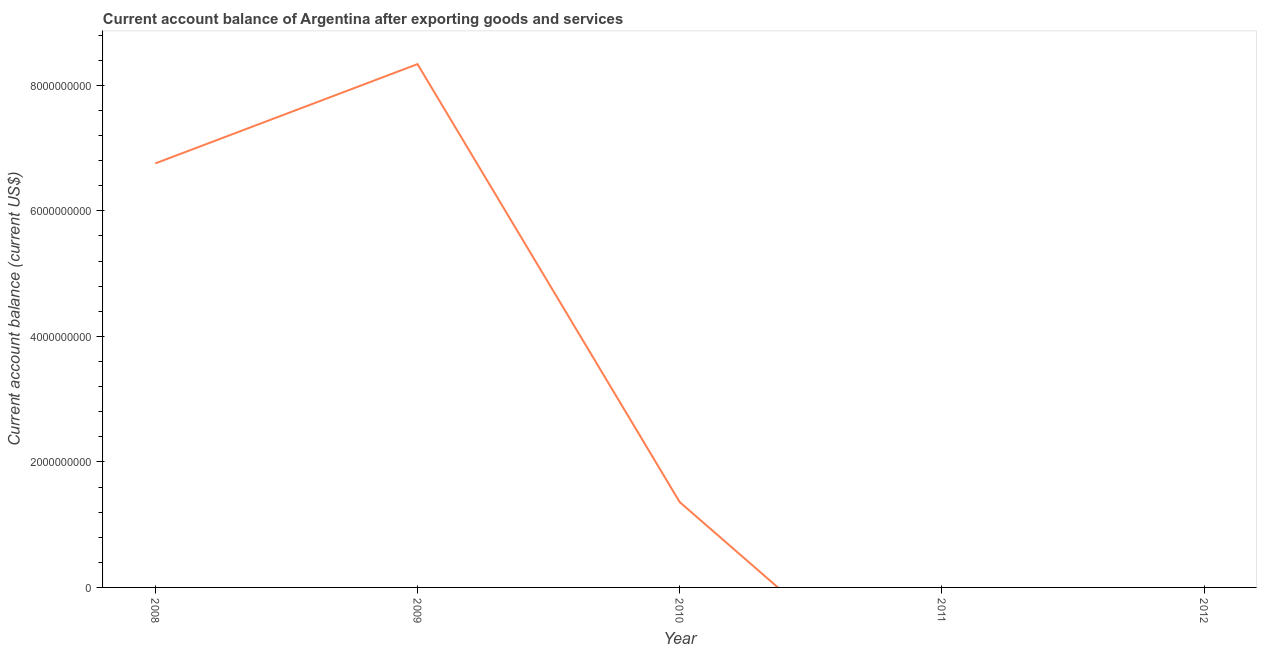What is the current account balance in 2009?
Offer a very short reply. 8.34e+09. Across all years, what is the maximum current account balance?
Provide a short and direct response. 8.34e+09. Across all years, what is the minimum current account balance?
Keep it short and to the point. 0. In which year was the current account balance maximum?
Offer a terse response. 2009. What is the sum of the current account balance?
Give a very brief answer. 1.65e+1. What is the difference between the current account balance in 2008 and 2009?
Provide a succinct answer. -1.58e+09. What is the average current account balance per year?
Your answer should be compact. 3.29e+09. What is the median current account balance?
Ensure brevity in your answer.  1.36e+09. In how many years, is the current account balance greater than 400000000 US$?
Ensure brevity in your answer.  3. What is the ratio of the current account balance in 2008 to that in 2009?
Offer a terse response. 0.81. Is the current account balance in 2009 less than that in 2010?
Offer a very short reply. No. What is the difference between the highest and the second highest current account balance?
Your answer should be compact. 1.58e+09. Is the sum of the current account balance in 2009 and 2010 greater than the maximum current account balance across all years?
Offer a terse response. Yes. What is the difference between the highest and the lowest current account balance?
Your response must be concise. 8.34e+09. In how many years, is the current account balance greater than the average current account balance taken over all years?
Your answer should be compact. 2. Does the current account balance monotonically increase over the years?
Ensure brevity in your answer.  No. How many years are there in the graph?
Provide a short and direct response. 5. What is the title of the graph?
Provide a succinct answer. Current account balance of Argentina after exporting goods and services. What is the label or title of the X-axis?
Provide a succinct answer. Year. What is the label or title of the Y-axis?
Provide a succinct answer. Current account balance (current US$). What is the Current account balance (current US$) in 2008?
Provide a succinct answer. 6.76e+09. What is the Current account balance (current US$) in 2009?
Your answer should be compact. 8.34e+09. What is the Current account balance (current US$) of 2010?
Keep it short and to the point. 1.36e+09. What is the Current account balance (current US$) of 2011?
Ensure brevity in your answer.  0. What is the difference between the Current account balance (current US$) in 2008 and 2009?
Offer a terse response. -1.58e+09. What is the difference between the Current account balance (current US$) in 2008 and 2010?
Offer a very short reply. 5.40e+09. What is the difference between the Current account balance (current US$) in 2009 and 2010?
Keep it short and to the point. 6.98e+09. What is the ratio of the Current account balance (current US$) in 2008 to that in 2009?
Make the answer very short. 0.81. What is the ratio of the Current account balance (current US$) in 2008 to that in 2010?
Provide a succinct answer. 4.97. What is the ratio of the Current account balance (current US$) in 2009 to that in 2010?
Ensure brevity in your answer.  6.13. 